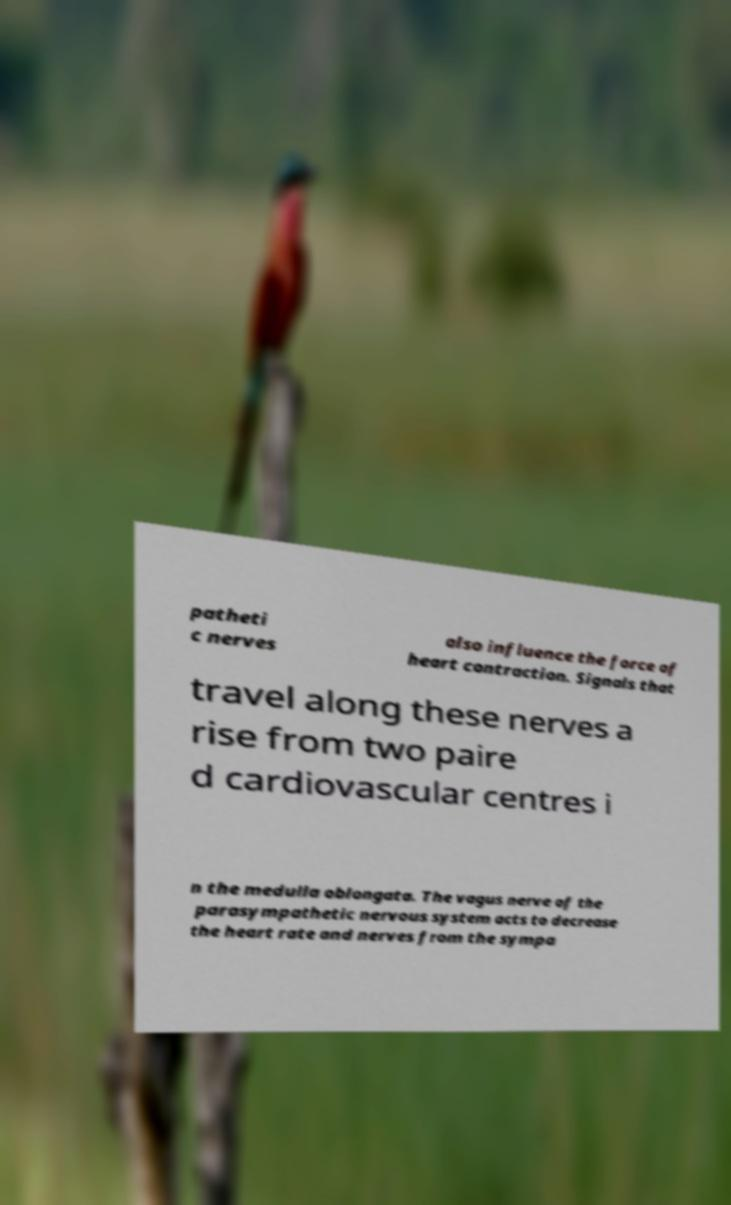I need the written content from this picture converted into text. Can you do that? patheti c nerves also influence the force of heart contraction. Signals that travel along these nerves a rise from two paire d cardiovascular centres i n the medulla oblongata. The vagus nerve of the parasympathetic nervous system acts to decrease the heart rate and nerves from the sympa 